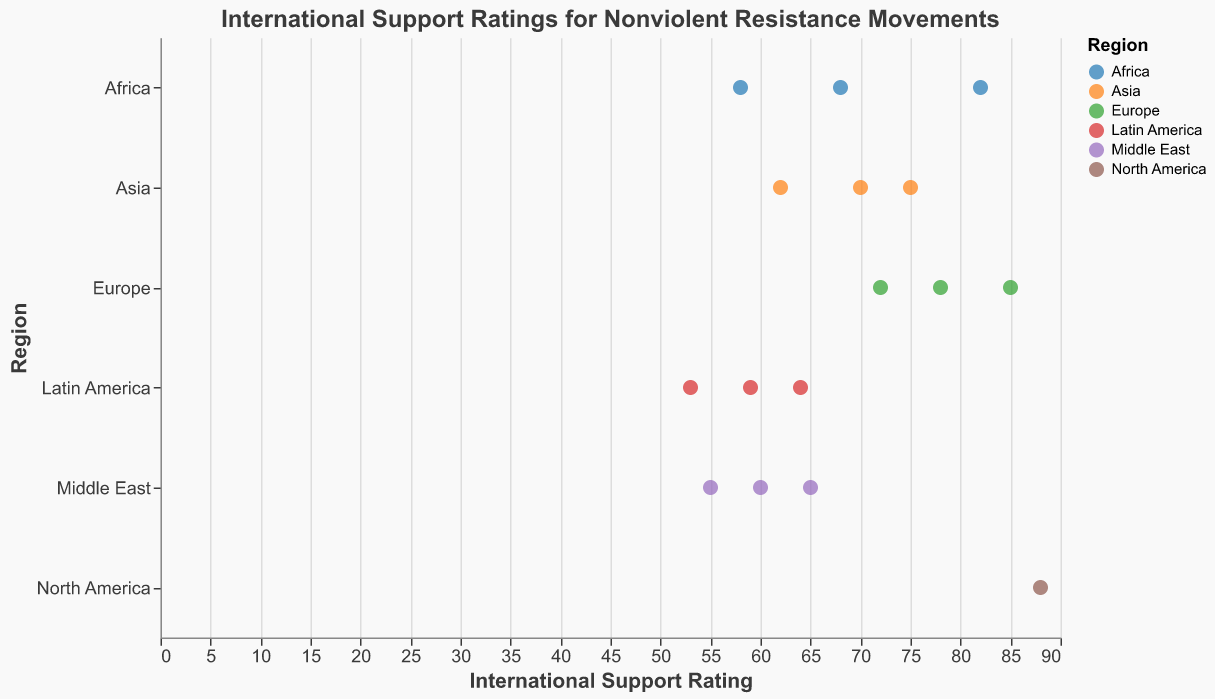What is the average international support rating for movements in Asia? The ratings for Asia are 70, 75, and 62. Summing these, we have 70 + 75 + 62 = 207. Dividing by 3 (the number of movements) gives us 207 / 3 = 69.
Answer: 69 Which region has the highest international support rating overall? The highest rating in the dataset is 88, which belongs to the Civil Rights Movement (USA) from North America. Therefore, North America has the highest international support rating.
Answer: North America What is the range of international support ratings for movements in Europe? The ratings for Europe are 85, 78, and 72. The range is the difference between the highest and lowest values: 85 - 72 = 13.
Answer: 13 How many movements in total are represented in the plot? By counting the number of data points, we can see that there are 16 movements represented in the plot.
Answer: 16 Among the movements in the Middle East, which one received the lowest international support rating? The support ratings for the Middle East are 65, 60, and 55. The lowest rating here is 55, which is for the Green Movement (Iran).
Answer: Green Movement (Iran) Compare the international support ratings for the Anti-Apartheid Movement and the Nicaraguan Revolution. Which one has a higher rating? The Anti-Apartheid Movement has a rating of 82, and the Nicaraguan Revolution has a rating of 64. Therefore, the Anti-Apartheid Movement has a higher rating.
Answer: Anti-Apartheid Movement What is the median international support rating for the movements in Latin America? The ratings are 64, 59, and 53. Arranging these in ascending order gives 53, 59, and 64. The median value, which is the middle number, is 59.
Answer: 59 If you sum the international support ratings for all movements in Africa, what is the total? The ratings are 82, 68, and 58. Their sum is 82 + 68 + 58 = 208.
Answer: 208 Identify the movement with the highest international support rating in Europe. The ratings for Europe are 85, 78, and 72. The highest rating is 85, which belongs to the Polish Solidarity movement.
Answer: Polish Solidarity What is the difference in international support ratings between the Sudanese Revolution and the Saffron Revolution (Myanmar)? The rating for the Sudanese Revolution is 68, and for the Saffron Revolution (Myanmar) it is 70. The difference is 70 - 68 = 2.
Answer: 2 